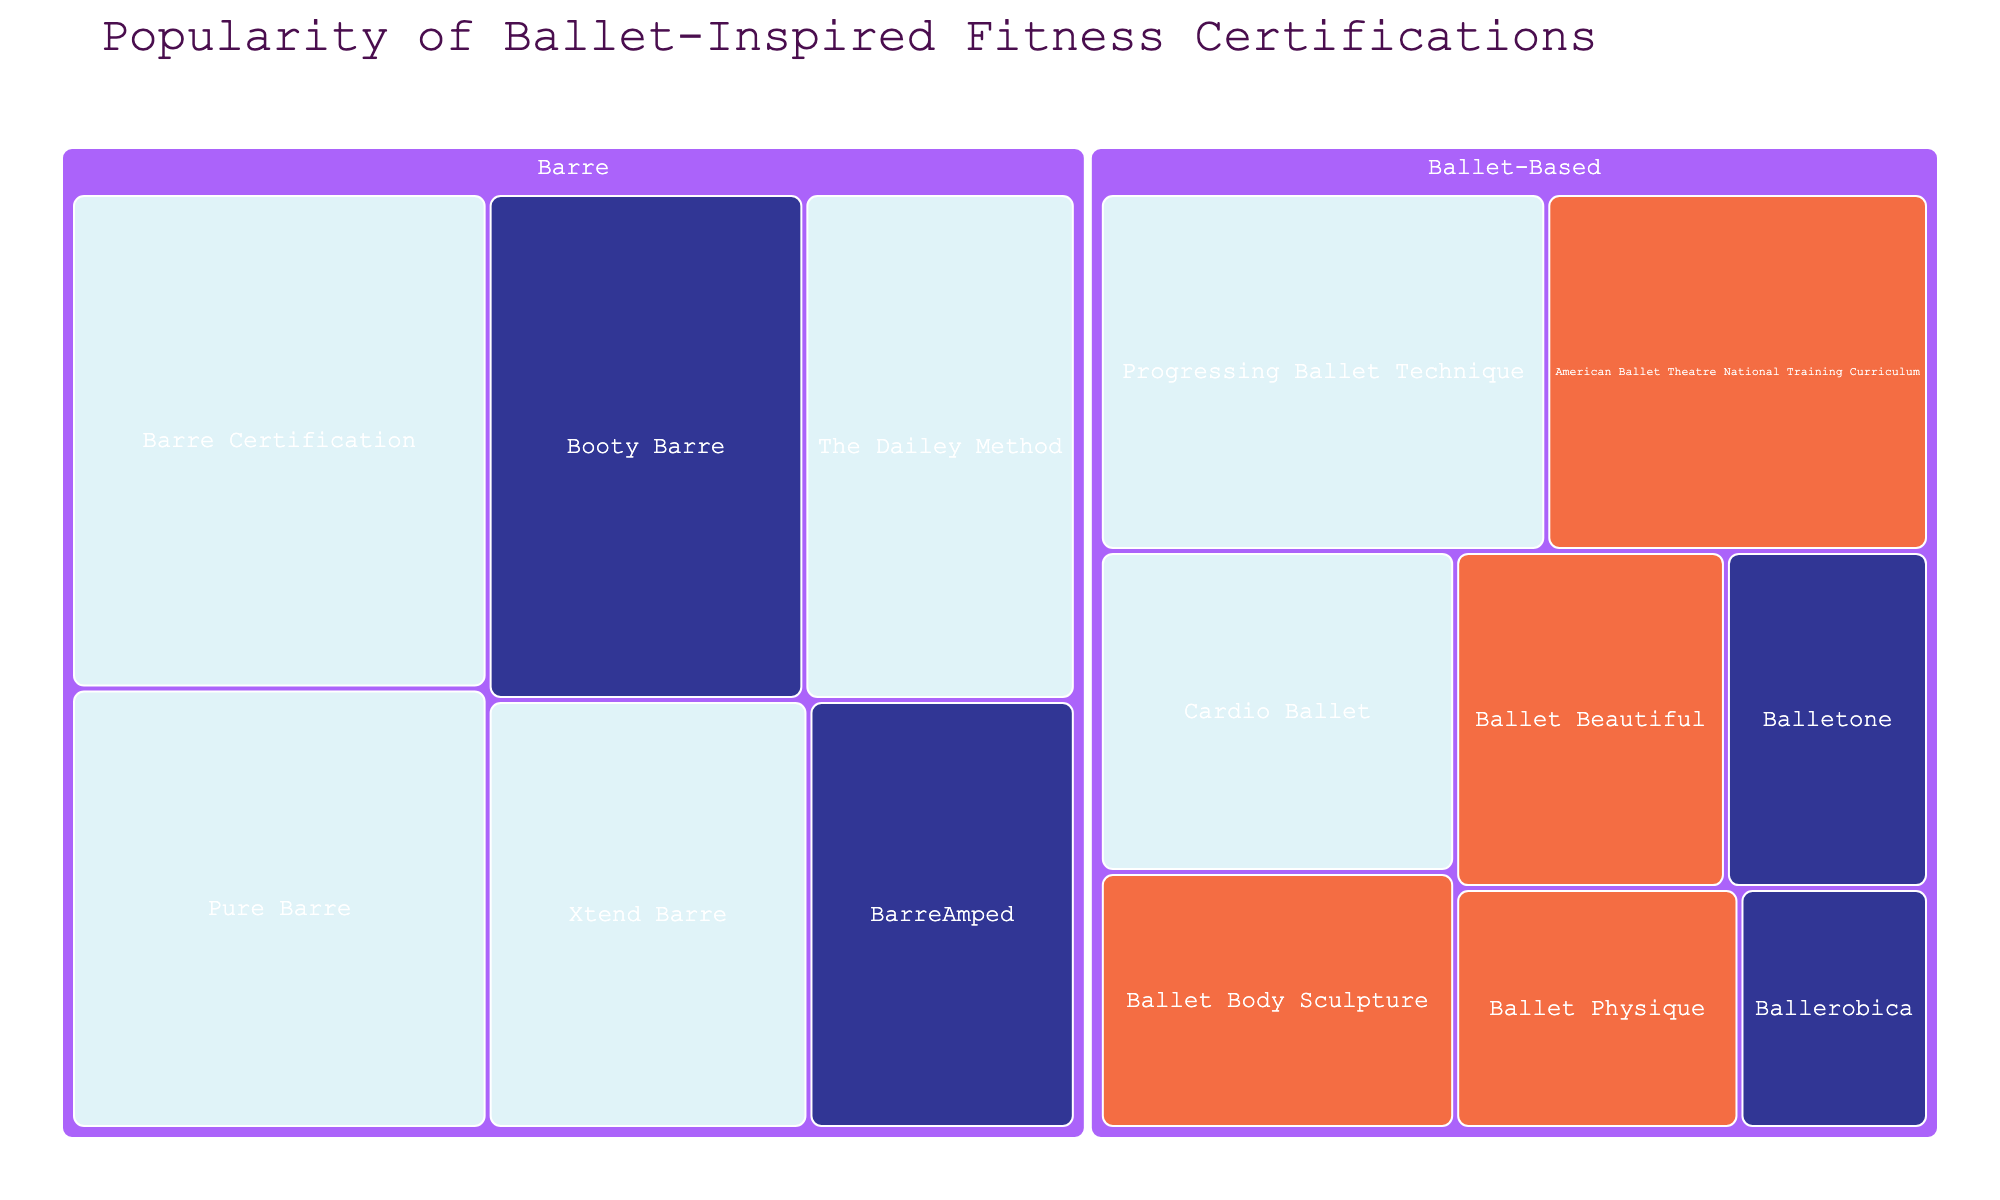what is the title of the Treemap? The title is a central aspect of the figure's layout, usually positioned at the top. It provides a clear indication of the main topic or subject of the Treemap.
Answer: Popularity of Ballet-Inspired Fitness Certifications what certification type has the most intermediate difficulty programs? To identify the certification type with the most intermediate difficulty programs, we need to count the number of intermediate difficulty certifications in each type (Barre or Ballet-Based). Barre has four intermediate programs (Barre Certification, Pure Barre, The Dailey Method, Xtend Barre) compared to Ballet-Based, which has two (Progressing Ballet Technique, Cardio Ballet).
Answer: Barre what is the total popularity of all Advanced difficulty programs? Sum the popularity of all programs marked as Advanced difficulty: 30 (American Ballet Theatre National Training Curriculum) + 20 (Ballet Body Sculpture) + 20 (Ballet Beautiful) + 15 (Ballet Physique) = 85.
Answer: 85 how does the popularity of BarreAmped compare to Booty Barre? Check the popularity values of both BarreAmped (25) and Booty Barre (35). Compare these values directly to determine which is higher or lower.
Answer: Booty Barre is more popular what program has the lowest popularity among beginner difficulty programs? Look for the beginner difficulty programs and find the one with the lowest popularity. The programs and their popularity are: BarreAmped (25), Booty Barre (35), Balletone (15), Ballerobica (10). Ballerobica has the lowest popularity.
Answer: Ballerobica what is the combined popularity of the 'Barre' type certifications? Add the popularity values of all programs classified under the 'Barre' type: 45 (Barre Certification) + 25 (BarreAmped) + 40 (Pure Barre) + 30 (The Dailey Method) + 35 (Booty Barre) + 30 (Xtend Barre) = 205.
Answer: 205 which Ballet-Based certification has the highest popularity? Identify the Ballet-Based certifications and compare their popularity values. The programs are: American Ballet Theatre National Training Curriculum (30), Progressing Ballet Technique (35), Ballet Body Sculpture (20), Balletone (15), Cardio Ballet (25), Ballet Beautiful (20), Ballet Physique (15), Ballerobica (10). Progressing Ballet Technique has the highest popularity with a value of 35.
Answer: Progressing Ballet Technique how many certifications are there in total? Count all the individual programs listed in the Treemap regardless of their type or difficulty level. There are 14 programs in total.
Answer: 14 